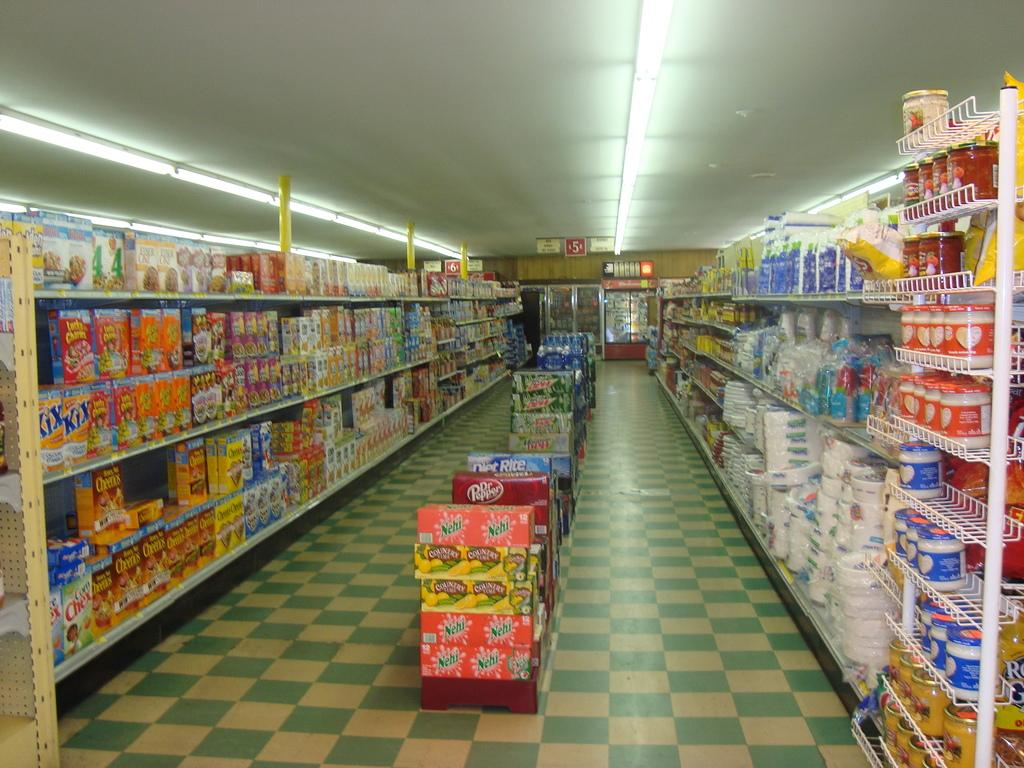Provide a one-sentence caption for the provided image. The box of Kix cereal is at the very end of the left aisle. 